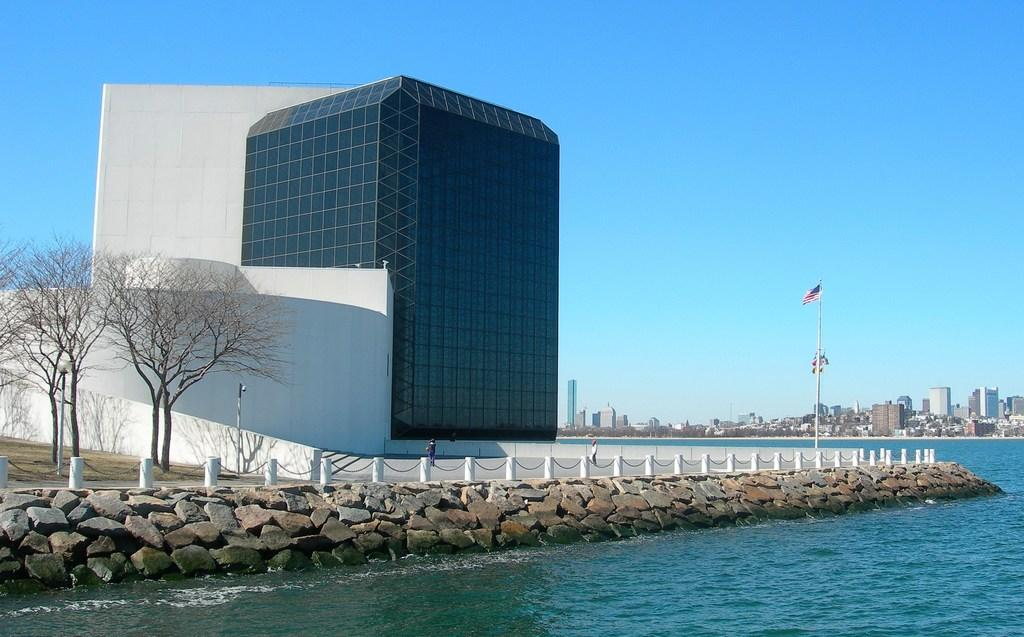What is one of the natural elements present in the image? There is water in the image. What type of geological formation can be seen in the image? There are rocks in the image. What man-made structures are present in the image? There are poles, a flag, buildings, and possibly the flagpole in the image. What type of vegetation is present in the image? There are trees in the image. What is visible in the background of the image? The sky is visible in the background of the image. Can you describe the seat that is present in the image? There is no seat present in the image. What type of thoughts or ideas are depicted in the image? The image does not depict thoughts or ideas; it is a visual representation of various elements such as water, rocks, poles, a flag, trees, buildings, and the sky. 